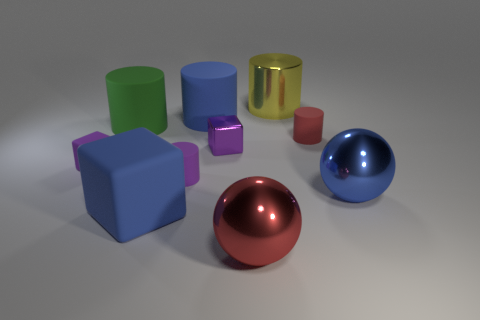There is another block that is the same color as the tiny rubber cube; what material is it?
Give a very brief answer. Metal. Is the color of the small metal block the same as the small matte block?
Provide a succinct answer. Yes. Are any small blue matte things visible?
Your answer should be compact. No. There is a small purple thing on the right side of the purple thing that is in front of the purple rubber block; are there any purple metallic blocks that are right of it?
Ensure brevity in your answer.  No. Does the tiny metal object have the same shape as the large blue rubber thing that is in front of the small metal block?
Ensure brevity in your answer.  Yes. The large cylinder that is to the right of the small purple object to the right of the blue rubber thing that is behind the green matte cylinder is what color?
Ensure brevity in your answer.  Yellow. How many things are either tiny cylinders on the right side of the red sphere or metal things to the left of the large blue shiny ball?
Your answer should be compact. 4. How many other things are there of the same color as the large metal cylinder?
Your answer should be very brief. 0. Is the shape of the shiny object behind the tiny red thing the same as  the green rubber thing?
Your answer should be compact. Yes. Is the number of blue objects in front of the small purple rubber cylinder less than the number of purple shiny things?
Provide a succinct answer. No. 